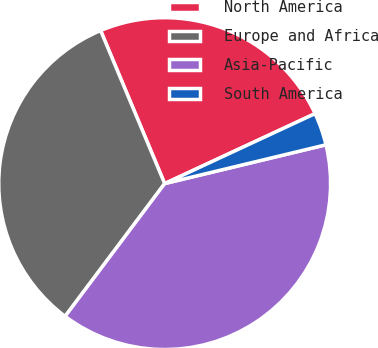Convert chart to OTSL. <chart><loc_0><loc_0><loc_500><loc_500><pie_chart><fcel>North America<fcel>Europe and Africa<fcel>Asia-Pacific<fcel>South America<nl><fcel>24.38%<fcel>33.45%<fcel>39.0%<fcel>3.17%<nl></chart> 